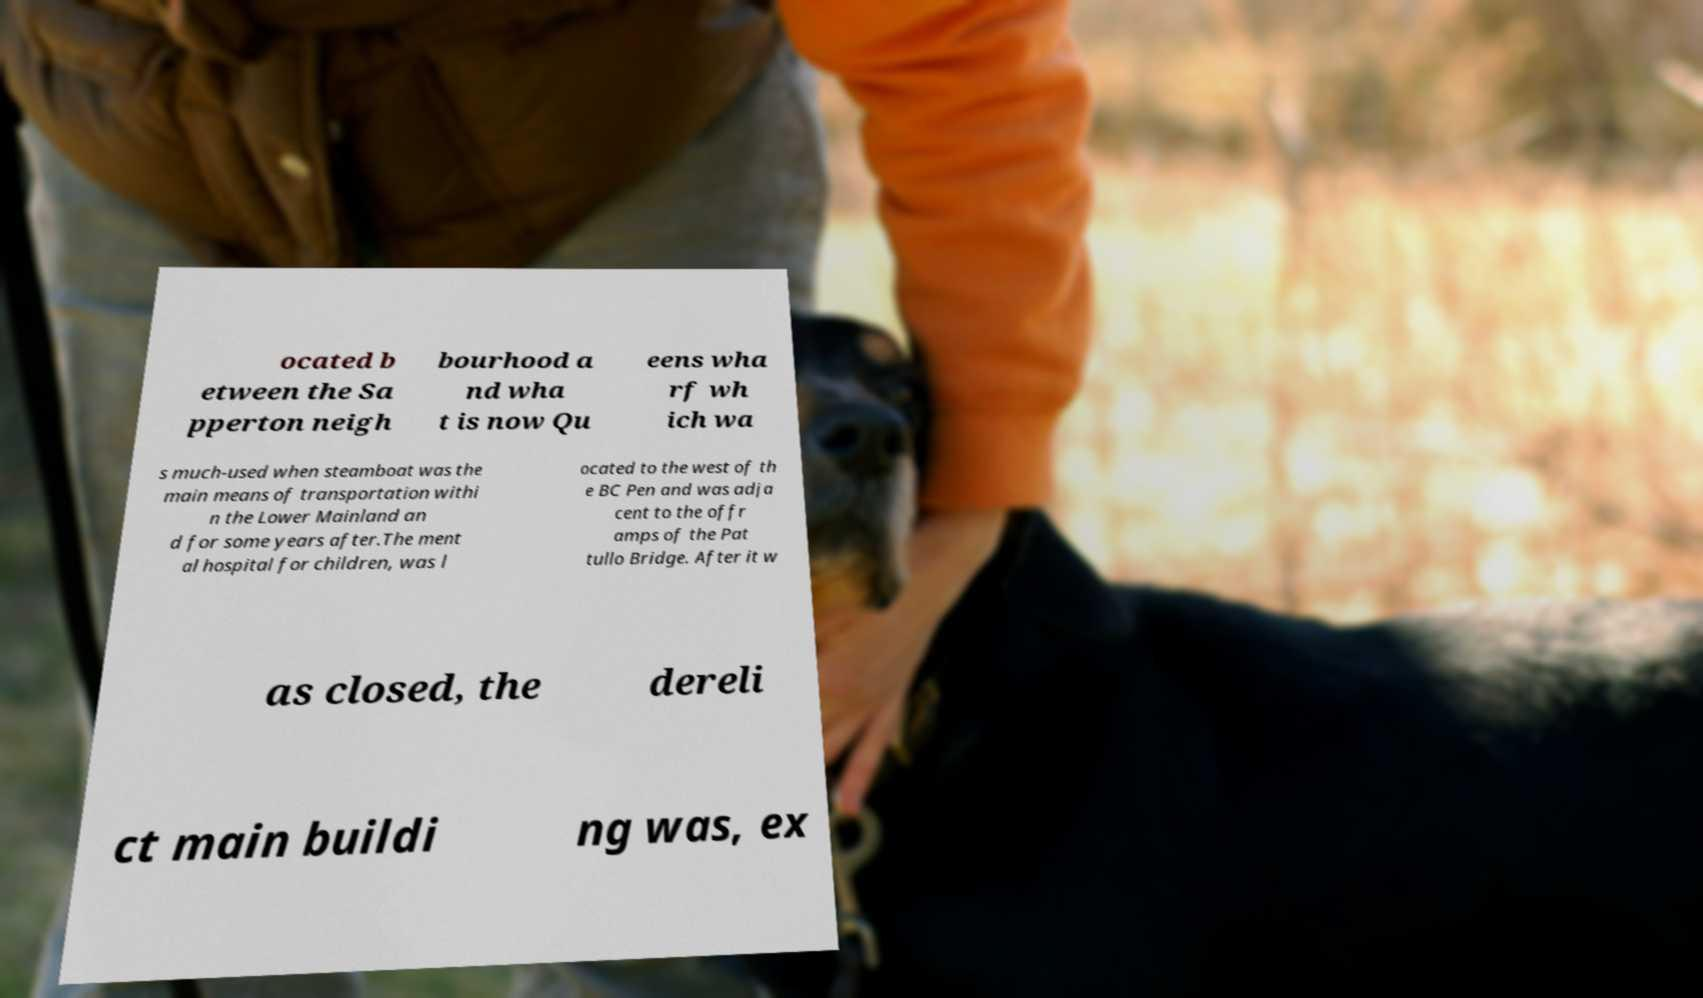Can you accurately transcribe the text from the provided image for me? ocated b etween the Sa pperton neigh bourhood a nd wha t is now Qu eens wha rf wh ich wa s much-used when steamboat was the main means of transportation withi n the Lower Mainland an d for some years after.The ment al hospital for children, was l ocated to the west of th e BC Pen and was adja cent to the offr amps of the Pat tullo Bridge. After it w as closed, the dereli ct main buildi ng was, ex 